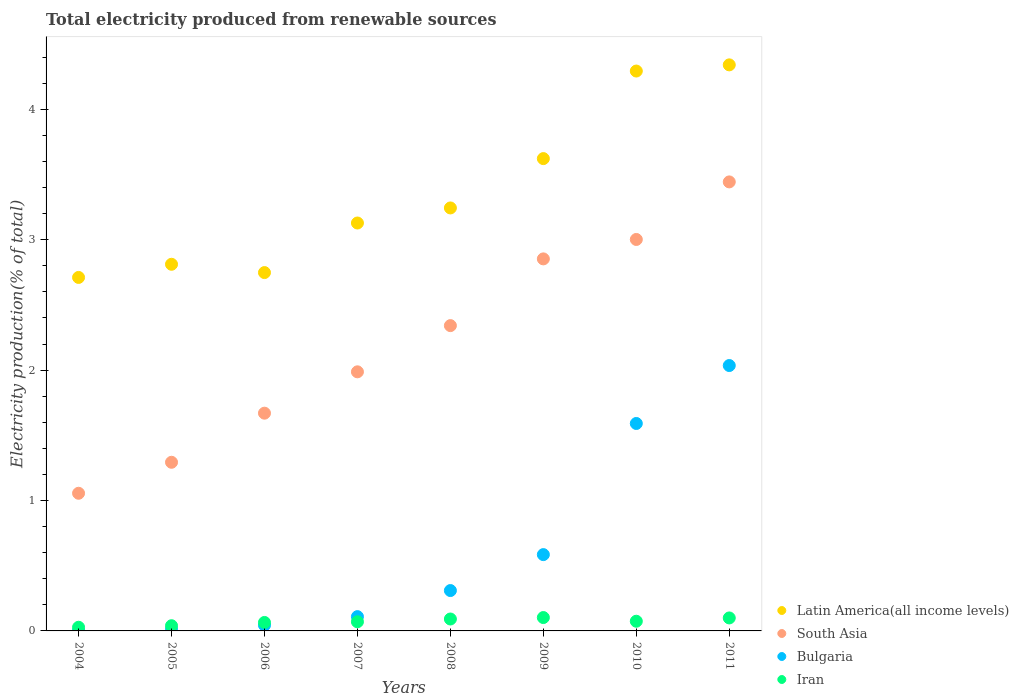Is the number of dotlines equal to the number of legend labels?
Offer a very short reply. Yes. What is the total electricity produced in Iran in 2010?
Offer a terse response. 0.07. Across all years, what is the maximum total electricity produced in South Asia?
Provide a short and direct response. 3.44. Across all years, what is the minimum total electricity produced in South Asia?
Keep it short and to the point. 1.06. In which year was the total electricity produced in South Asia maximum?
Your response must be concise. 2011. What is the total total electricity produced in Iran in the graph?
Keep it short and to the point. 0.57. What is the difference between the total electricity produced in Bulgaria in 2006 and that in 2009?
Keep it short and to the point. -0.54. What is the difference between the total electricity produced in Latin America(all income levels) in 2006 and the total electricity produced in Iran in 2011?
Your answer should be very brief. 2.65. What is the average total electricity produced in Iran per year?
Your response must be concise. 0.07. In the year 2008, what is the difference between the total electricity produced in Iran and total electricity produced in South Asia?
Offer a very short reply. -2.25. What is the ratio of the total electricity produced in Bulgaria in 2005 to that in 2008?
Make the answer very short. 0.04. Is the total electricity produced in Iran in 2007 less than that in 2008?
Make the answer very short. Yes. Is the difference between the total electricity produced in Iran in 2004 and 2009 greater than the difference between the total electricity produced in South Asia in 2004 and 2009?
Ensure brevity in your answer.  Yes. What is the difference between the highest and the second highest total electricity produced in Bulgaria?
Your answer should be compact. 0.44. What is the difference between the highest and the lowest total electricity produced in Bulgaria?
Make the answer very short. 2.03. In how many years, is the total electricity produced in Iran greater than the average total electricity produced in Iran taken over all years?
Your response must be concise. 4. Is it the case that in every year, the sum of the total electricity produced in Bulgaria and total electricity produced in Latin America(all income levels)  is greater than the sum of total electricity produced in Iran and total electricity produced in South Asia?
Your response must be concise. No. Is it the case that in every year, the sum of the total electricity produced in South Asia and total electricity produced in Iran  is greater than the total electricity produced in Latin America(all income levels)?
Provide a short and direct response. No. How many years are there in the graph?
Offer a very short reply. 8. What is the difference between two consecutive major ticks on the Y-axis?
Your answer should be very brief. 1. Are the values on the major ticks of Y-axis written in scientific E-notation?
Your response must be concise. No. Does the graph contain any zero values?
Keep it short and to the point. No. Does the graph contain grids?
Offer a terse response. No. How many legend labels are there?
Offer a very short reply. 4. What is the title of the graph?
Your answer should be very brief. Total electricity produced from renewable sources. What is the label or title of the X-axis?
Offer a terse response. Years. What is the label or title of the Y-axis?
Ensure brevity in your answer.  Electricity production(% of total). What is the Electricity production(% of total) in Latin America(all income levels) in 2004?
Provide a succinct answer. 2.71. What is the Electricity production(% of total) of South Asia in 2004?
Give a very brief answer. 1.06. What is the Electricity production(% of total) in Bulgaria in 2004?
Your answer should be very brief. 0. What is the Electricity production(% of total) in Iran in 2004?
Your answer should be very brief. 0.03. What is the Electricity production(% of total) in Latin America(all income levels) in 2005?
Your response must be concise. 2.81. What is the Electricity production(% of total) in South Asia in 2005?
Provide a short and direct response. 1.29. What is the Electricity production(% of total) in Bulgaria in 2005?
Keep it short and to the point. 0.01. What is the Electricity production(% of total) in Iran in 2005?
Provide a short and direct response. 0.04. What is the Electricity production(% of total) in Latin America(all income levels) in 2006?
Make the answer very short. 2.75. What is the Electricity production(% of total) in South Asia in 2006?
Keep it short and to the point. 1.67. What is the Electricity production(% of total) of Bulgaria in 2006?
Give a very brief answer. 0.04. What is the Electricity production(% of total) in Iran in 2006?
Ensure brevity in your answer.  0.06. What is the Electricity production(% of total) in Latin America(all income levels) in 2007?
Give a very brief answer. 3.13. What is the Electricity production(% of total) in South Asia in 2007?
Your answer should be very brief. 1.99. What is the Electricity production(% of total) in Bulgaria in 2007?
Keep it short and to the point. 0.11. What is the Electricity production(% of total) of Iran in 2007?
Ensure brevity in your answer.  0.07. What is the Electricity production(% of total) of Latin America(all income levels) in 2008?
Provide a succinct answer. 3.24. What is the Electricity production(% of total) of South Asia in 2008?
Ensure brevity in your answer.  2.34. What is the Electricity production(% of total) in Bulgaria in 2008?
Provide a short and direct response. 0.31. What is the Electricity production(% of total) in Iran in 2008?
Offer a terse response. 0.09. What is the Electricity production(% of total) of Latin America(all income levels) in 2009?
Your response must be concise. 3.62. What is the Electricity production(% of total) of South Asia in 2009?
Ensure brevity in your answer.  2.85. What is the Electricity production(% of total) in Bulgaria in 2009?
Keep it short and to the point. 0.59. What is the Electricity production(% of total) in Iran in 2009?
Offer a very short reply. 0.1. What is the Electricity production(% of total) in Latin America(all income levels) in 2010?
Your response must be concise. 4.29. What is the Electricity production(% of total) of South Asia in 2010?
Your response must be concise. 3. What is the Electricity production(% of total) in Bulgaria in 2010?
Provide a short and direct response. 1.59. What is the Electricity production(% of total) of Iran in 2010?
Keep it short and to the point. 0.07. What is the Electricity production(% of total) in Latin America(all income levels) in 2011?
Provide a short and direct response. 4.34. What is the Electricity production(% of total) in South Asia in 2011?
Your answer should be compact. 3.44. What is the Electricity production(% of total) in Bulgaria in 2011?
Make the answer very short. 2.04. What is the Electricity production(% of total) of Iran in 2011?
Your answer should be compact. 0.1. Across all years, what is the maximum Electricity production(% of total) in Latin America(all income levels)?
Offer a terse response. 4.34. Across all years, what is the maximum Electricity production(% of total) of South Asia?
Offer a very short reply. 3.44. Across all years, what is the maximum Electricity production(% of total) of Bulgaria?
Ensure brevity in your answer.  2.04. Across all years, what is the maximum Electricity production(% of total) in Iran?
Keep it short and to the point. 0.1. Across all years, what is the minimum Electricity production(% of total) in Latin America(all income levels)?
Offer a very short reply. 2.71. Across all years, what is the minimum Electricity production(% of total) in South Asia?
Provide a short and direct response. 1.06. Across all years, what is the minimum Electricity production(% of total) in Bulgaria?
Make the answer very short. 0. Across all years, what is the minimum Electricity production(% of total) of Iran?
Make the answer very short. 0.03. What is the total Electricity production(% of total) in Latin America(all income levels) in the graph?
Your answer should be compact. 26.9. What is the total Electricity production(% of total) in South Asia in the graph?
Offer a terse response. 17.64. What is the total Electricity production(% of total) in Bulgaria in the graph?
Provide a succinct answer. 4.69. What is the total Electricity production(% of total) in Iran in the graph?
Offer a very short reply. 0.57. What is the difference between the Electricity production(% of total) in Latin America(all income levels) in 2004 and that in 2005?
Make the answer very short. -0.1. What is the difference between the Electricity production(% of total) in South Asia in 2004 and that in 2005?
Provide a succinct answer. -0.24. What is the difference between the Electricity production(% of total) of Bulgaria in 2004 and that in 2005?
Provide a succinct answer. -0.01. What is the difference between the Electricity production(% of total) of Iran in 2004 and that in 2005?
Make the answer very short. -0.01. What is the difference between the Electricity production(% of total) in Latin America(all income levels) in 2004 and that in 2006?
Your answer should be very brief. -0.04. What is the difference between the Electricity production(% of total) in South Asia in 2004 and that in 2006?
Your answer should be very brief. -0.61. What is the difference between the Electricity production(% of total) in Bulgaria in 2004 and that in 2006?
Offer a terse response. -0.04. What is the difference between the Electricity production(% of total) of Iran in 2004 and that in 2006?
Keep it short and to the point. -0.04. What is the difference between the Electricity production(% of total) of Latin America(all income levels) in 2004 and that in 2007?
Your answer should be very brief. -0.42. What is the difference between the Electricity production(% of total) of South Asia in 2004 and that in 2007?
Your response must be concise. -0.93. What is the difference between the Electricity production(% of total) of Bulgaria in 2004 and that in 2007?
Provide a succinct answer. -0.11. What is the difference between the Electricity production(% of total) in Iran in 2004 and that in 2007?
Your answer should be very brief. -0.04. What is the difference between the Electricity production(% of total) in Latin America(all income levels) in 2004 and that in 2008?
Give a very brief answer. -0.53. What is the difference between the Electricity production(% of total) of South Asia in 2004 and that in 2008?
Your answer should be very brief. -1.29. What is the difference between the Electricity production(% of total) in Bulgaria in 2004 and that in 2008?
Offer a very short reply. -0.31. What is the difference between the Electricity production(% of total) in Iran in 2004 and that in 2008?
Your answer should be compact. -0.06. What is the difference between the Electricity production(% of total) in Latin America(all income levels) in 2004 and that in 2009?
Give a very brief answer. -0.91. What is the difference between the Electricity production(% of total) in South Asia in 2004 and that in 2009?
Make the answer very short. -1.8. What is the difference between the Electricity production(% of total) of Bulgaria in 2004 and that in 2009?
Offer a very short reply. -0.58. What is the difference between the Electricity production(% of total) in Iran in 2004 and that in 2009?
Offer a terse response. -0.07. What is the difference between the Electricity production(% of total) in Latin America(all income levels) in 2004 and that in 2010?
Offer a very short reply. -1.58. What is the difference between the Electricity production(% of total) in South Asia in 2004 and that in 2010?
Keep it short and to the point. -1.95. What is the difference between the Electricity production(% of total) in Bulgaria in 2004 and that in 2010?
Offer a very short reply. -1.59. What is the difference between the Electricity production(% of total) of Iran in 2004 and that in 2010?
Your answer should be very brief. -0.05. What is the difference between the Electricity production(% of total) of Latin America(all income levels) in 2004 and that in 2011?
Provide a short and direct response. -1.63. What is the difference between the Electricity production(% of total) in South Asia in 2004 and that in 2011?
Your answer should be compact. -2.39. What is the difference between the Electricity production(% of total) in Bulgaria in 2004 and that in 2011?
Keep it short and to the point. -2.03. What is the difference between the Electricity production(% of total) of Iran in 2004 and that in 2011?
Your answer should be compact. -0.07. What is the difference between the Electricity production(% of total) of Latin America(all income levels) in 2005 and that in 2006?
Give a very brief answer. 0.06. What is the difference between the Electricity production(% of total) of South Asia in 2005 and that in 2006?
Your response must be concise. -0.38. What is the difference between the Electricity production(% of total) of Bulgaria in 2005 and that in 2006?
Offer a terse response. -0.03. What is the difference between the Electricity production(% of total) of Iran in 2005 and that in 2006?
Your answer should be compact. -0.03. What is the difference between the Electricity production(% of total) in Latin America(all income levels) in 2005 and that in 2007?
Provide a succinct answer. -0.32. What is the difference between the Electricity production(% of total) of South Asia in 2005 and that in 2007?
Offer a very short reply. -0.69. What is the difference between the Electricity production(% of total) of Bulgaria in 2005 and that in 2007?
Ensure brevity in your answer.  -0.1. What is the difference between the Electricity production(% of total) of Iran in 2005 and that in 2007?
Ensure brevity in your answer.  -0.03. What is the difference between the Electricity production(% of total) in Latin America(all income levels) in 2005 and that in 2008?
Offer a very short reply. -0.43. What is the difference between the Electricity production(% of total) in South Asia in 2005 and that in 2008?
Ensure brevity in your answer.  -1.05. What is the difference between the Electricity production(% of total) of Bulgaria in 2005 and that in 2008?
Your answer should be very brief. -0.3. What is the difference between the Electricity production(% of total) in Iran in 2005 and that in 2008?
Offer a terse response. -0.05. What is the difference between the Electricity production(% of total) in Latin America(all income levels) in 2005 and that in 2009?
Your answer should be compact. -0.81. What is the difference between the Electricity production(% of total) of South Asia in 2005 and that in 2009?
Make the answer very short. -1.56. What is the difference between the Electricity production(% of total) of Bulgaria in 2005 and that in 2009?
Provide a succinct answer. -0.57. What is the difference between the Electricity production(% of total) in Iran in 2005 and that in 2009?
Your answer should be compact. -0.06. What is the difference between the Electricity production(% of total) in Latin America(all income levels) in 2005 and that in 2010?
Keep it short and to the point. -1.48. What is the difference between the Electricity production(% of total) of South Asia in 2005 and that in 2010?
Give a very brief answer. -1.71. What is the difference between the Electricity production(% of total) of Bulgaria in 2005 and that in 2010?
Provide a short and direct response. -1.58. What is the difference between the Electricity production(% of total) in Iran in 2005 and that in 2010?
Keep it short and to the point. -0.03. What is the difference between the Electricity production(% of total) of Latin America(all income levels) in 2005 and that in 2011?
Keep it short and to the point. -1.53. What is the difference between the Electricity production(% of total) in South Asia in 2005 and that in 2011?
Provide a succinct answer. -2.15. What is the difference between the Electricity production(% of total) of Bulgaria in 2005 and that in 2011?
Your answer should be very brief. -2.02. What is the difference between the Electricity production(% of total) in Iran in 2005 and that in 2011?
Provide a short and direct response. -0.06. What is the difference between the Electricity production(% of total) of Latin America(all income levels) in 2006 and that in 2007?
Make the answer very short. -0.38. What is the difference between the Electricity production(% of total) of South Asia in 2006 and that in 2007?
Provide a short and direct response. -0.32. What is the difference between the Electricity production(% of total) of Bulgaria in 2006 and that in 2007?
Keep it short and to the point. -0.07. What is the difference between the Electricity production(% of total) in Iran in 2006 and that in 2007?
Ensure brevity in your answer.  -0.01. What is the difference between the Electricity production(% of total) of Latin America(all income levels) in 2006 and that in 2008?
Provide a short and direct response. -0.5. What is the difference between the Electricity production(% of total) in South Asia in 2006 and that in 2008?
Offer a very short reply. -0.67. What is the difference between the Electricity production(% of total) in Bulgaria in 2006 and that in 2008?
Your response must be concise. -0.27. What is the difference between the Electricity production(% of total) of Iran in 2006 and that in 2008?
Ensure brevity in your answer.  -0.03. What is the difference between the Electricity production(% of total) in Latin America(all income levels) in 2006 and that in 2009?
Your response must be concise. -0.87. What is the difference between the Electricity production(% of total) of South Asia in 2006 and that in 2009?
Give a very brief answer. -1.18. What is the difference between the Electricity production(% of total) in Bulgaria in 2006 and that in 2009?
Provide a succinct answer. -0.54. What is the difference between the Electricity production(% of total) of Iran in 2006 and that in 2009?
Your answer should be very brief. -0.04. What is the difference between the Electricity production(% of total) of Latin America(all income levels) in 2006 and that in 2010?
Keep it short and to the point. -1.55. What is the difference between the Electricity production(% of total) in South Asia in 2006 and that in 2010?
Your answer should be compact. -1.33. What is the difference between the Electricity production(% of total) of Bulgaria in 2006 and that in 2010?
Make the answer very short. -1.55. What is the difference between the Electricity production(% of total) of Iran in 2006 and that in 2010?
Offer a very short reply. -0.01. What is the difference between the Electricity production(% of total) in Latin America(all income levels) in 2006 and that in 2011?
Ensure brevity in your answer.  -1.59. What is the difference between the Electricity production(% of total) in South Asia in 2006 and that in 2011?
Give a very brief answer. -1.77. What is the difference between the Electricity production(% of total) of Bulgaria in 2006 and that in 2011?
Provide a short and direct response. -1.99. What is the difference between the Electricity production(% of total) in Iran in 2006 and that in 2011?
Ensure brevity in your answer.  -0.03. What is the difference between the Electricity production(% of total) of Latin America(all income levels) in 2007 and that in 2008?
Your response must be concise. -0.12. What is the difference between the Electricity production(% of total) of South Asia in 2007 and that in 2008?
Provide a short and direct response. -0.35. What is the difference between the Electricity production(% of total) of Bulgaria in 2007 and that in 2008?
Give a very brief answer. -0.2. What is the difference between the Electricity production(% of total) in Iran in 2007 and that in 2008?
Your answer should be very brief. -0.02. What is the difference between the Electricity production(% of total) of Latin America(all income levels) in 2007 and that in 2009?
Make the answer very short. -0.49. What is the difference between the Electricity production(% of total) in South Asia in 2007 and that in 2009?
Keep it short and to the point. -0.87. What is the difference between the Electricity production(% of total) in Bulgaria in 2007 and that in 2009?
Make the answer very short. -0.48. What is the difference between the Electricity production(% of total) of Iran in 2007 and that in 2009?
Make the answer very short. -0.03. What is the difference between the Electricity production(% of total) in Latin America(all income levels) in 2007 and that in 2010?
Give a very brief answer. -1.17. What is the difference between the Electricity production(% of total) in South Asia in 2007 and that in 2010?
Make the answer very short. -1.01. What is the difference between the Electricity production(% of total) in Bulgaria in 2007 and that in 2010?
Ensure brevity in your answer.  -1.48. What is the difference between the Electricity production(% of total) in Iran in 2007 and that in 2010?
Give a very brief answer. -0. What is the difference between the Electricity production(% of total) in Latin America(all income levels) in 2007 and that in 2011?
Ensure brevity in your answer.  -1.21. What is the difference between the Electricity production(% of total) in South Asia in 2007 and that in 2011?
Ensure brevity in your answer.  -1.46. What is the difference between the Electricity production(% of total) in Bulgaria in 2007 and that in 2011?
Keep it short and to the point. -1.93. What is the difference between the Electricity production(% of total) of Iran in 2007 and that in 2011?
Provide a short and direct response. -0.03. What is the difference between the Electricity production(% of total) of Latin America(all income levels) in 2008 and that in 2009?
Your response must be concise. -0.38. What is the difference between the Electricity production(% of total) in South Asia in 2008 and that in 2009?
Your response must be concise. -0.51. What is the difference between the Electricity production(% of total) in Bulgaria in 2008 and that in 2009?
Offer a terse response. -0.28. What is the difference between the Electricity production(% of total) in Iran in 2008 and that in 2009?
Make the answer very short. -0.01. What is the difference between the Electricity production(% of total) of Latin America(all income levels) in 2008 and that in 2010?
Your response must be concise. -1.05. What is the difference between the Electricity production(% of total) in South Asia in 2008 and that in 2010?
Provide a short and direct response. -0.66. What is the difference between the Electricity production(% of total) in Bulgaria in 2008 and that in 2010?
Offer a very short reply. -1.28. What is the difference between the Electricity production(% of total) of Iran in 2008 and that in 2010?
Provide a succinct answer. 0.02. What is the difference between the Electricity production(% of total) in Latin America(all income levels) in 2008 and that in 2011?
Make the answer very short. -1.1. What is the difference between the Electricity production(% of total) in South Asia in 2008 and that in 2011?
Offer a terse response. -1.1. What is the difference between the Electricity production(% of total) in Bulgaria in 2008 and that in 2011?
Provide a succinct answer. -1.73. What is the difference between the Electricity production(% of total) in Iran in 2008 and that in 2011?
Your response must be concise. -0.01. What is the difference between the Electricity production(% of total) in Latin America(all income levels) in 2009 and that in 2010?
Ensure brevity in your answer.  -0.67. What is the difference between the Electricity production(% of total) of South Asia in 2009 and that in 2010?
Your response must be concise. -0.15. What is the difference between the Electricity production(% of total) in Bulgaria in 2009 and that in 2010?
Offer a very short reply. -1.01. What is the difference between the Electricity production(% of total) in Iran in 2009 and that in 2010?
Give a very brief answer. 0.03. What is the difference between the Electricity production(% of total) in Latin America(all income levels) in 2009 and that in 2011?
Offer a terse response. -0.72. What is the difference between the Electricity production(% of total) in South Asia in 2009 and that in 2011?
Your answer should be very brief. -0.59. What is the difference between the Electricity production(% of total) in Bulgaria in 2009 and that in 2011?
Your response must be concise. -1.45. What is the difference between the Electricity production(% of total) of Iran in 2009 and that in 2011?
Keep it short and to the point. 0. What is the difference between the Electricity production(% of total) in Latin America(all income levels) in 2010 and that in 2011?
Keep it short and to the point. -0.05. What is the difference between the Electricity production(% of total) in South Asia in 2010 and that in 2011?
Keep it short and to the point. -0.44. What is the difference between the Electricity production(% of total) in Bulgaria in 2010 and that in 2011?
Ensure brevity in your answer.  -0.44. What is the difference between the Electricity production(% of total) of Iran in 2010 and that in 2011?
Make the answer very short. -0.03. What is the difference between the Electricity production(% of total) of Latin America(all income levels) in 2004 and the Electricity production(% of total) of South Asia in 2005?
Offer a terse response. 1.42. What is the difference between the Electricity production(% of total) in Latin America(all income levels) in 2004 and the Electricity production(% of total) in Bulgaria in 2005?
Your answer should be compact. 2.7. What is the difference between the Electricity production(% of total) in Latin America(all income levels) in 2004 and the Electricity production(% of total) in Iran in 2005?
Keep it short and to the point. 2.67. What is the difference between the Electricity production(% of total) of South Asia in 2004 and the Electricity production(% of total) of Bulgaria in 2005?
Make the answer very short. 1.04. What is the difference between the Electricity production(% of total) of South Asia in 2004 and the Electricity production(% of total) of Iran in 2005?
Offer a terse response. 1.02. What is the difference between the Electricity production(% of total) of Bulgaria in 2004 and the Electricity production(% of total) of Iran in 2005?
Offer a terse response. -0.04. What is the difference between the Electricity production(% of total) of Latin America(all income levels) in 2004 and the Electricity production(% of total) of South Asia in 2006?
Provide a succinct answer. 1.04. What is the difference between the Electricity production(% of total) in Latin America(all income levels) in 2004 and the Electricity production(% of total) in Bulgaria in 2006?
Offer a terse response. 2.67. What is the difference between the Electricity production(% of total) of Latin America(all income levels) in 2004 and the Electricity production(% of total) of Iran in 2006?
Your response must be concise. 2.65. What is the difference between the Electricity production(% of total) of South Asia in 2004 and the Electricity production(% of total) of Bulgaria in 2006?
Provide a short and direct response. 1.01. What is the difference between the Electricity production(% of total) in South Asia in 2004 and the Electricity production(% of total) in Iran in 2006?
Your answer should be compact. 0.99. What is the difference between the Electricity production(% of total) in Bulgaria in 2004 and the Electricity production(% of total) in Iran in 2006?
Provide a succinct answer. -0.06. What is the difference between the Electricity production(% of total) in Latin America(all income levels) in 2004 and the Electricity production(% of total) in South Asia in 2007?
Your response must be concise. 0.72. What is the difference between the Electricity production(% of total) of Latin America(all income levels) in 2004 and the Electricity production(% of total) of Bulgaria in 2007?
Offer a very short reply. 2.6. What is the difference between the Electricity production(% of total) in Latin America(all income levels) in 2004 and the Electricity production(% of total) in Iran in 2007?
Your answer should be compact. 2.64. What is the difference between the Electricity production(% of total) in South Asia in 2004 and the Electricity production(% of total) in Bulgaria in 2007?
Your answer should be very brief. 0.95. What is the difference between the Electricity production(% of total) of South Asia in 2004 and the Electricity production(% of total) of Iran in 2007?
Provide a short and direct response. 0.99. What is the difference between the Electricity production(% of total) of Bulgaria in 2004 and the Electricity production(% of total) of Iran in 2007?
Make the answer very short. -0.07. What is the difference between the Electricity production(% of total) in Latin America(all income levels) in 2004 and the Electricity production(% of total) in South Asia in 2008?
Provide a succinct answer. 0.37. What is the difference between the Electricity production(% of total) in Latin America(all income levels) in 2004 and the Electricity production(% of total) in Bulgaria in 2008?
Offer a very short reply. 2.4. What is the difference between the Electricity production(% of total) in Latin America(all income levels) in 2004 and the Electricity production(% of total) in Iran in 2008?
Keep it short and to the point. 2.62. What is the difference between the Electricity production(% of total) in South Asia in 2004 and the Electricity production(% of total) in Bulgaria in 2008?
Give a very brief answer. 0.75. What is the difference between the Electricity production(% of total) in South Asia in 2004 and the Electricity production(% of total) in Iran in 2008?
Offer a very short reply. 0.96. What is the difference between the Electricity production(% of total) of Bulgaria in 2004 and the Electricity production(% of total) of Iran in 2008?
Offer a very short reply. -0.09. What is the difference between the Electricity production(% of total) in Latin America(all income levels) in 2004 and the Electricity production(% of total) in South Asia in 2009?
Offer a very short reply. -0.14. What is the difference between the Electricity production(% of total) in Latin America(all income levels) in 2004 and the Electricity production(% of total) in Bulgaria in 2009?
Your answer should be compact. 2.13. What is the difference between the Electricity production(% of total) in Latin America(all income levels) in 2004 and the Electricity production(% of total) in Iran in 2009?
Make the answer very short. 2.61. What is the difference between the Electricity production(% of total) in South Asia in 2004 and the Electricity production(% of total) in Bulgaria in 2009?
Offer a very short reply. 0.47. What is the difference between the Electricity production(% of total) in South Asia in 2004 and the Electricity production(% of total) in Iran in 2009?
Ensure brevity in your answer.  0.95. What is the difference between the Electricity production(% of total) in Bulgaria in 2004 and the Electricity production(% of total) in Iran in 2009?
Your answer should be very brief. -0.1. What is the difference between the Electricity production(% of total) of Latin America(all income levels) in 2004 and the Electricity production(% of total) of South Asia in 2010?
Offer a very short reply. -0.29. What is the difference between the Electricity production(% of total) of Latin America(all income levels) in 2004 and the Electricity production(% of total) of Bulgaria in 2010?
Your answer should be compact. 1.12. What is the difference between the Electricity production(% of total) in Latin America(all income levels) in 2004 and the Electricity production(% of total) in Iran in 2010?
Offer a very short reply. 2.64. What is the difference between the Electricity production(% of total) in South Asia in 2004 and the Electricity production(% of total) in Bulgaria in 2010?
Provide a succinct answer. -0.54. What is the difference between the Electricity production(% of total) of South Asia in 2004 and the Electricity production(% of total) of Iran in 2010?
Offer a very short reply. 0.98. What is the difference between the Electricity production(% of total) of Bulgaria in 2004 and the Electricity production(% of total) of Iran in 2010?
Offer a terse response. -0.07. What is the difference between the Electricity production(% of total) of Latin America(all income levels) in 2004 and the Electricity production(% of total) of South Asia in 2011?
Offer a terse response. -0.73. What is the difference between the Electricity production(% of total) of Latin America(all income levels) in 2004 and the Electricity production(% of total) of Bulgaria in 2011?
Your answer should be compact. 0.68. What is the difference between the Electricity production(% of total) of Latin America(all income levels) in 2004 and the Electricity production(% of total) of Iran in 2011?
Make the answer very short. 2.61. What is the difference between the Electricity production(% of total) in South Asia in 2004 and the Electricity production(% of total) in Bulgaria in 2011?
Provide a short and direct response. -0.98. What is the difference between the Electricity production(% of total) in South Asia in 2004 and the Electricity production(% of total) in Iran in 2011?
Your answer should be very brief. 0.96. What is the difference between the Electricity production(% of total) in Bulgaria in 2004 and the Electricity production(% of total) in Iran in 2011?
Offer a terse response. -0.1. What is the difference between the Electricity production(% of total) in Latin America(all income levels) in 2005 and the Electricity production(% of total) in South Asia in 2006?
Provide a short and direct response. 1.14. What is the difference between the Electricity production(% of total) in Latin America(all income levels) in 2005 and the Electricity production(% of total) in Bulgaria in 2006?
Offer a very short reply. 2.77. What is the difference between the Electricity production(% of total) in Latin America(all income levels) in 2005 and the Electricity production(% of total) in Iran in 2006?
Provide a short and direct response. 2.75. What is the difference between the Electricity production(% of total) of South Asia in 2005 and the Electricity production(% of total) of Bulgaria in 2006?
Your answer should be compact. 1.25. What is the difference between the Electricity production(% of total) in South Asia in 2005 and the Electricity production(% of total) in Iran in 2006?
Make the answer very short. 1.23. What is the difference between the Electricity production(% of total) of Bulgaria in 2005 and the Electricity production(% of total) of Iran in 2006?
Your response must be concise. -0.05. What is the difference between the Electricity production(% of total) of Latin America(all income levels) in 2005 and the Electricity production(% of total) of South Asia in 2007?
Give a very brief answer. 0.82. What is the difference between the Electricity production(% of total) of Latin America(all income levels) in 2005 and the Electricity production(% of total) of Bulgaria in 2007?
Give a very brief answer. 2.7. What is the difference between the Electricity production(% of total) in Latin America(all income levels) in 2005 and the Electricity production(% of total) in Iran in 2007?
Make the answer very short. 2.74. What is the difference between the Electricity production(% of total) of South Asia in 2005 and the Electricity production(% of total) of Bulgaria in 2007?
Give a very brief answer. 1.18. What is the difference between the Electricity production(% of total) of South Asia in 2005 and the Electricity production(% of total) of Iran in 2007?
Make the answer very short. 1.22. What is the difference between the Electricity production(% of total) of Bulgaria in 2005 and the Electricity production(% of total) of Iran in 2007?
Offer a terse response. -0.06. What is the difference between the Electricity production(% of total) in Latin America(all income levels) in 2005 and the Electricity production(% of total) in South Asia in 2008?
Provide a succinct answer. 0.47. What is the difference between the Electricity production(% of total) in Latin America(all income levels) in 2005 and the Electricity production(% of total) in Bulgaria in 2008?
Offer a terse response. 2.5. What is the difference between the Electricity production(% of total) in Latin America(all income levels) in 2005 and the Electricity production(% of total) in Iran in 2008?
Ensure brevity in your answer.  2.72. What is the difference between the Electricity production(% of total) in South Asia in 2005 and the Electricity production(% of total) in Bulgaria in 2008?
Ensure brevity in your answer.  0.98. What is the difference between the Electricity production(% of total) in South Asia in 2005 and the Electricity production(% of total) in Iran in 2008?
Give a very brief answer. 1.2. What is the difference between the Electricity production(% of total) in Bulgaria in 2005 and the Electricity production(% of total) in Iran in 2008?
Offer a very short reply. -0.08. What is the difference between the Electricity production(% of total) in Latin America(all income levels) in 2005 and the Electricity production(% of total) in South Asia in 2009?
Provide a short and direct response. -0.04. What is the difference between the Electricity production(% of total) of Latin America(all income levels) in 2005 and the Electricity production(% of total) of Bulgaria in 2009?
Your answer should be very brief. 2.23. What is the difference between the Electricity production(% of total) in Latin America(all income levels) in 2005 and the Electricity production(% of total) in Iran in 2009?
Make the answer very short. 2.71. What is the difference between the Electricity production(% of total) of South Asia in 2005 and the Electricity production(% of total) of Bulgaria in 2009?
Your response must be concise. 0.71. What is the difference between the Electricity production(% of total) of South Asia in 2005 and the Electricity production(% of total) of Iran in 2009?
Your response must be concise. 1.19. What is the difference between the Electricity production(% of total) of Bulgaria in 2005 and the Electricity production(% of total) of Iran in 2009?
Your answer should be compact. -0.09. What is the difference between the Electricity production(% of total) of Latin America(all income levels) in 2005 and the Electricity production(% of total) of South Asia in 2010?
Provide a short and direct response. -0.19. What is the difference between the Electricity production(% of total) in Latin America(all income levels) in 2005 and the Electricity production(% of total) in Bulgaria in 2010?
Make the answer very short. 1.22. What is the difference between the Electricity production(% of total) of Latin America(all income levels) in 2005 and the Electricity production(% of total) of Iran in 2010?
Ensure brevity in your answer.  2.74. What is the difference between the Electricity production(% of total) in South Asia in 2005 and the Electricity production(% of total) in Bulgaria in 2010?
Your answer should be very brief. -0.3. What is the difference between the Electricity production(% of total) of South Asia in 2005 and the Electricity production(% of total) of Iran in 2010?
Offer a terse response. 1.22. What is the difference between the Electricity production(% of total) of Bulgaria in 2005 and the Electricity production(% of total) of Iran in 2010?
Your answer should be very brief. -0.06. What is the difference between the Electricity production(% of total) of Latin America(all income levels) in 2005 and the Electricity production(% of total) of South Asia in 2011?
Your answer should be very brief. -0.63. What is the difference between the Electricity production(% of total) of Latin America(all income levels) in 2005 and the Electricity production(% of total) of Bulgaria in 2011?
Your response must be concise. 0.78. What is the difference between the Electricity production(% of total) of Latin America(all income levels) in 2005 and the Electricity production(% of total) of Iran in 2011?
Ensure brevity in your answer.  2.71. What is the difference between the Electricity production(% of total) of South Asia in 2005 and the Electricity production(% of total) of Bulgaria in 2011?
Your answer should be compact. -0.74. What is the difference between the Electricity production(% of total) of South Asia in 2005 and the Electricity production(% of total) of Iran in 2011?
Give a very brief answer. 1.19. What is the difference between the Electricity production(% of total) in Bulgaria in 2005 and the Electricity production(% of total) in Iran in 2011?
Provide a succinct answer. -0.09. What is the difference between the Electricity production(% of total) of Latin America(all income levels) in 2006 and the Electricity production(% of total) of South Asia in 2007?
Give a very brief answer. 0.76. What is the difference between the Electricity production(% of total) in Latin America(all income levels) in 2006 and the Electricity production(% of total) in Bulgaria in 2007?
Ensure brevity in your answer.  2.64. What is the difference between the Electricity production(% of total) in Latin America(all income levels) in 2006 and the Electricity production(% of total) in Iran in 2007?
Offer a very short reply. 2.68. What is the difference between the Electricity production(% of total) of South Asia in 2006 and the Electricity production(% of total) of Bulgaria in 2007?
Your response must be concise. 1.56. What is the difference between the Electricity production(% of total) of South Asia in 2006 and the Electricity production(% of total) of Iran in 2007?
Your response must be concise. 1.6. What is the difference between the Electricity production(% of total) in Bulgaria in 2006 and the Electricity production(% of total) in Iran in 2007?
Provide a succinct answer. -0.03. What is the difference between the Electricity production(% of total) of Latin America(all income levels) in 2006 and the Electricity production(% of total) of South Asia in 2008?
Your answer should be very brief. 0.41. What is the difference between the Electricity production(% of total) in Latin America(all income levels) in 2006 and the Electricity production(% of total) in Bulgaria in 2008?
Your answer should be compact. 2.44. What is the difference between the Electricity production(% of total) of Latin America(all income levels) in 2006 and the Electricity production(% of total) of Iran in 2008?
Give a very brief answer. 2.66. What is the difference between the Electricity production(% of total) in South Asia in 2006 and the Electricity production(% of total) in Bulgaria in 2008?
Your answer should be compact. 1.36. What is the difference between the Electricity production(% of total) in South Asia in 2006 and the Electricity production(% of total) in Iran in 2008?
Provide a succinct answer. 1.58. What is the difference between the Electricity production(% of total) of Bulgaria in 2006 and the Electricity production(% of total) of Iran in 2008?
Offer a very short reply. -0.05. What is the difference between the Electricity production(% of total) in Latin America(all income levels) in 2006 and the Electricity production(% of total) in South Asia in 2009?
Give a very brief answer. -0.1. What is the difference between the Electricity production(% of total) of Latin America(all income levels) in 2006 and the Electricity production(% of total) of Bulgaria in 2009?
Provide a succinct answer. 2.16. What is the difference between the Electricity production(% of total) of Latin America(all income levels) in 2006 and the Electricity production(% of total) of Iran in 2009?
Provide a succinct answer. 2.65. What is the difference between the Electricity production(% of total) of South Asia in 2006 and the Electricity production(% of total) of Bulgaria in 2009?
Your response must be concise. 1.08. What is the difference between the Electricity production(% of total) in South Asia in 2006 and the Electricity production(% of total) in Iran in 2009?
Give a very brief answer. 1.57. What is the difference between the Electricity production(% of total) in Bulgaria in 2006 and the Electricity production(% of total) in Iran in 2009?
Offer a terse response. -0.06. What is the difference between the Electricity production(% of total) of Latin America(all income levels) in 2006 and the Electricity production(% of total) of South Asia in 2010?
Provide a short and direct response. -0.25. What is the difference between the Electricity production(% of total) in Latin America(all income levels) in 2006 and the Electricity production(% of total) in Bulgaria in 2010?
Provide a short and direct response. 1.16. What is the difference between the Electricity production(% of total) of Latin America(all income levels) in 2006 and the Electricity production(% of total) of Iran in 2010?
Provide a short and direct response. 2.67. What is the difference between the Electricity production(% of total) in South Asia in 2006 and the Electricity production(% of total) in Bulgaria in 2010?
Ensure brevity in your answer.  0.08. What is the difference between the Electricity production(% of total) in South Asia in 2006 and the Electricity production(% of total) in Iran in 2010?
Your answer should be very brief. 1.6. What is the difference between the Electricity production(% of total) of Bulgaria in 2006 and the Electricity production(% of total) of Iran in 2010?
Ensure brevity in your answer.  -0.03. What is the difference between the Electricity production(% of total) of Latin America(all income levels) in 2006 and the Electricity production(% of total) of South Asia in 2011?
Provide a short and direct response. -0.7. What is the difference between the Electricity production(% of total) in Latin America(all income levels) in 2006 and the Electricity production(% of total) in Bulgaria in 2011?
Provide a short and direct response. 0.71. What is the difference between the Electricity production(% of total) of Latin America(all income levels) in 2006 and the Electricity production(% of total) of Iran in 2011?
Your answer should be very brief. 2.65. What is the difference between the Electricity production(% of total) in South Asia in 2006 and the Electricity production(% of total) in Bulgaria in 2011?
Offer a terse response. -0.37. What is the difference between the Electricity production(% of total) of South Asia in 2006 and the Electricity production(% of total) of Iran in 2011?
Your answer should be very brief. 1.57. What is the difference between the Electricity production(% of total) of Bulgaria in 2006 and the Electricity production(% of total) of Iran in 2011?
Keep it short and to the point. -0.06. What is the difference between the Electricity production(% of total) in Latin America(all income levels) in 2007 and the Electricity production(% of total) in South Asia in 2008?
Offer a very short reply. 0.79. What is the difference between the Electricity production(% of total) of Latin America(all income levels) in 2007 and the Electricity production(% of total) of Bulgaria in 2008?
Your answer should be very brief. 2.82. What is the difference between the Electricity production(% of total) of Latin America(all income levels) in 2007 and the Electricity production(% of total) of Iran in 2008?
Provide a succinct answer. 3.04. What is the difference between the Electricity production(% of total) in South Asia in 2007 and the Electricity production(% of total) in Bulgaria in 2008?
Your answer should be compact. 1.68. What is the difference between the Electricity production(% of total) of South Asia in 2007 and the Electricity production(% of total) of Iran in 2008?
Give a very brief answer. 1.9. What is the difference between the Electricity production(% of total) in Bulgaria in 2007 and the Electricity production(% of total) in Iran in 2008?
Your answer should be very brief. 0.02. What is the difference between the Electricity production(% of total) of Latin America(all income levels) in 2007 and the Electricity production(% of total) of South Asia in 2009?
Your answer should be very brief. 0.28. What is the difference between the Electricity production(% of total) of Latin America(all income levels) in 2007 and the Electricity production(% of total) of Bulgaria in 2009?
Provide a succinct answer. 2.54. What is the difference between the Electricity production(% of total) in Latin America(all income levels) in 2007 and the Electricity production(% of total) in Iran in 2009?
Offer a terse response. 3.03. What is the difference between the Electricity production(% of total) in South Asia in 2007 and the Electricity production(% of total) in Bulgaria in 2009?
Your answer should be compact. 1.4. What is the difference between the Electricity production(% of total) of South Asia in 2007 and the Electricity production(% of total) of Iran in 2009?
Offer a terse response. 1.88. What is the difference between the Electricity production(% of total) of Bulgaria in 2007 and the Electricity production(% of total) of Iran in 2009?
Give a very brief answer. 0.01. What is the difference between the Electricity production(% of total) of Latin America(all income levels) in 2007 and the Electricity production(% of total) of South Asia in 2010?
Make the answer very short. 0.13. What is the difference between the Electricity production(% of total) in Latin America(all income levels) in 2007 and the Electricity production(% of total) in Bulgaria in 2010?
Provide a short and direct response. 1.54. What is the difference between the Electricity production(% of total) of Latin America(all income levels) in 2007 and the Electricity production(% of total) of Iran in 2010?
Provide a short and direct response. 3.05. What is the difference between the Electricity production(% of total) in South Asia in 2007 and the Electricity production(% of total) in Bulgaria in 2010?
Your answer should be very brief. 0.4. What is the difference between the Electricity production(% of total) in South Asia in 2007 and the Electricity production(% of total) in Iran in 2010?
Provide a short and direct response. 1.91. What is the difference between the Electricity production(% of total) in Bulgaria in 2007 and the Electricity production(% of total) in Iran in 2010?
Offer a very short reply. 0.04. What is the difference between the Electricity production(% of total) in Latin America(all income levels) in 2007 and the Electricity production(% of total) in South Asia in 2011?
Make the answer very short. -0.32. What is the difference between the Electricity production(% of total) in Latin America(all income levels) in 2007 and the Electricity production(% of total) in Bulgaria in 2011?
Keep it short and to the point. 1.09. What is the difference between the Electricity production(% of total) of Latin America(all income levels) in 2007 and the Electricity production(% of total) of Iran in 2011?
Provide a succinct answer. 3.03. What is the difference between the Electricity production(% of total) of South Asia in 2007 and the Electricity production(% of total) of Bulgaria in 2011?
Ensure brevity in your answer.  -0.05. What is the difference between the Electricity production(% of total) of South Asia in 2007 and the Electricity production(% of total) of Iran in 2011?
Offer a very short reply. 1.89. What is the difference between the Electricity production(% of total) of Bulgaria in 2007 and the Electricity production(% of total) of Iran in 2011?
Offer a terse response. 0.01. What is the difference between the Electricity production(% of total) in Latin America(all income levels) in 2008 and the Electricity production(% of total) in South Asia in 2009?
Offer a terse response. 0.39. What is the difference between the Electricity production(% of total) in Latin America(all income levels) in 2008 and the Electricity production(% of total) in Bulgaria in 2009?
Your answer should be very brief. 2.66. What is the difference between the Electricity production(% of total) in Latin America(all income levels) in 2008 and the Electricity production(% of total) in Iran in 2009?
Your answer should be very brief. 3.14. What is the difference between the Electricity production(% of total) in South Asia in 2008 and the Electricity production(% of total) in Bulgaria in 2009?
Your answer should be very brief. 1.76. What is the difference between the Electricity production(% of total) in South Asia in 2008 and the Electricity production(% of total) in Iran in 2009?
Ensure brevity in your answer.  2.24. What is the difference between the Electricity production(% of total) of Bulgaria in 2008 and the Electricity production(% of total) of Iran in 2009?
Provide a short and direct response. 0.21. What is the difference between the Electricity production(% of total) of Latin America(all income levels) in 2008 and the Electricity production(% of total) of South Asia in 2010?
Provide a short and direct response. 0.24. What is the difference between the Electricity production(% of total) of Latin America(all income levels) in 2008 and the Electricity production(% of total) of Bulgaria in 2010?
Provide a succinct answer. 1.65. What is the difference between the Electricity production(% of total) of Latin America(all income levels) in 2008 and the Electricity production(% of total) of Iran in 2010?
Make the answer very short. 3.17. What is the difference between the Electricity production(% of total) of South Asia in 2008 and the Electricity production(% of total) of Bulgaria in 2010?
Offer a terse response. 0.75. What is the difference between the Electricity production(% of total) of South Asia in 2008 and the Electricity production(% of total) of Iran in 2010?
Your answer should be very brief. 2.27. What is the difference between the Electricity production(% of total) of Bulgaria in 2008 and the Electricity production(% of total) of Iran in 2010?
Your answer should be very brief. 0.24. What is the difference between the Electricity production(% of total) in Latin America(all income levels) in 2008 and the Electricity production(% of total) in South Asia in 2011?
Keep it short and to the point. -0.2. What is the difference between the Electricity production(% of total) in Latin America(all income levels) in 2008 and the Electricity production(% of total) in Bulgaria in 2011?
Give a very brief answer. 1.21. What is the difference between the Electricity production(% of total) in Latin America(all income levels) in 2008 and the Electricity production(% of total) in Iran in 2011?
Give a very brief answer. 3.14. What is the difference between the Electricity production(% of total) of South Asia in 2008 and the Electricity production(% of total) of Bulgaria in 2011?
Give a very brief answer. 0.31. What is the difference between the Electricity production(% of total) in South Asia in 2008 and the Electricity production(% of total) in Iran in 2011?
Provide a short and direct response. 2.24. What is the difference between the Electricity production(% of total) of Bulgaria in 2008 and the Electricity production(% of total) of Iran in 2011?
Your answer should be very brief. 0.21. What is the difference between the Electricity production(% of total) of Latin America(all income levels) in 2009 and the Electricity production(% of total) of South Asia in 2010?
Offer a very short reply. 0.62. What is the difference between the Electricity production(% of total) in Latin America(all income levels) in 2009 and the Electricity production(% of total) in Bulgaria in 2010?
Make the answer very short. 2.03. What is the difference between the Electricity production(% of total) of Latin America(all income levels) in 2009 and the Electricity production(% of total) of Iran in 2010?
Provide a short and direct response. 3.55. What is the difference between the Electricity production(% of total) in South Asia in 2009 and the Electricity production(% of total) in Bulgaria in 2010?
Ensure brevity in your answer.  1.26. What is the difference between the Electricity production(% of total) in South Asia in 2009 and the Electricity production(% of total) in Iran in 2010?
Provide a short and direct response. 2.78. What is the difference between the Electricity production(% of total) of Bulgaria in 2009 and the Electricity production(% of total) of Iran in 2010?
Offer a terse response. 0.51. What is the difference between the Electricity production(% of total) in Latin America(all income levels) in 2009 and the Electricity production(% of total) in South Asia in 2011?
Your answer should be very brief. 0.18. What is the difference between the Electricity production(% of total) of Latin America(all income levels) in 2009 and the Electricity production(% of total) of Bulgaria in 2011?
Make the answer very short. 1.59. What is the difference between the Electricity production(% of total) of Latin America(all income levels) in 2009 and the Electricity production(% of total) of Iran in 2011?
Your answer should be compact. 3.52. What is the difference between the Electricity production(% of total) of South Asia in 2009 and the Electricity production(% of total) of Bulgaria in 2011?
Your answer should be compact. 0.82. What is the difference between the Electricity production(% of total) in South Asia in 2009 and the Electricity production(% of total) in Iran in 2011?
Your answer should be very brief. 2.75. What is the difference between the Electricity production(% of total) of Bulgaria in 2009 and the Electricity production(% of total) of Iran in 2011?
Keep it short and to the point. 0.49. What is the difference between the Electricity production(% of total) of Latin America(all income levels) in 2010 and the Electricity production(% of total) of South Asia in 2011?
Ensure brevity in your answer.  0.85. What is the difference between the Electricity production(% of total) in Latin America(all income levels) in 2010 and the Electricity production(% of total) in Bulgaria in 2011?
Provide a succinct answer. 2.26. What is the difference between the Electricity production(% of total) of Latin America(all income levels) in 2010 and the Electricity production(% of total) of Iran in 2011?
Make the answer very short. 4.19. What is the difference between the Electricity production(% of total) of South Asia in 2010 and the Electricity production(% of total) of Bulgaria in 2011?
Your response must be concise. 0.97. What is the difference between the Electricity production(% of total) of South Asia in 2010 and the Electricity production(% of total) of Iran in 2011?
Your answer should be compact. 2.9. What is the difference between the Electricity production(% of total) in Bulgaria in 2010 and the Electricity production(% of total) in Iran in 2011?
Keep it short and to the point. 1.49. What is the average Electricity production(% of total) in Latin America(all income levels) per year?
Make the answer very short. 3.36. What is the average Electricity production(% of total) in South Asia per year?
Provide a succinct answer. 2.21. What is the average Electricity production(% of total) in Bulgaria per year?
Make the answer very short. 0.59. What is the average Electricity production(% of total) of Iran per year?
Your answer should be compact. 0.07. In the year 2004, what is the difference between the Electricity production(% of total) in Latin America(all income levels) and Electricity production(% of total) in South Asia?
Provide a short and direct response. 1.66. In the year 2004, what is the difference between the Electricity production(% of total) of Latin America(all income levels) and Electricity production(% of total) of Bulgaria?
Your answer should be very brief. 2.71. In the year 2004, what is the difference between the Electricity production(% of total) of Latin America(all income levels) and Electricity production(% of total) of Iran?
Ensure brevity in your answer.  2.68. In the year 2004, what is the difference between the Electricity production(% of total) in South Asia and Electricity production(% of total) in Bulgaria?
Your response must be concise. 1.05. In the year 2004, what is the difference between the Electricity production(% of total) in South Asia and Electricity production(% of total) in Iran?
Give a very brief answer. 1.03. In the year 2004, what is the difference between the Electricity production(% of total) of Bulgaria and Electricity production(% of total) of Iran?
Keep it short and to the point. -0.03. In the year 2005, what is the difference between the Electricity production(% of total) in Latin America(all income levels) and Electricity production(% of total) in South Asia?
Keep it short and to the point. 1.52. In the year 2005, what is the difference between the Electricity production(% of total) in Latin America(all income levels) and Electricity production(% of total) in Bulgaria?
Offer a terse response. 2.8. In the year 2005, what is the difference between the Electricity production(% of total) in Latin America(all income levels) and Electricity production(% of total) in Iran?
Provide a succinct answer. 2.77. In the year 2005, what is the difference between the Electricity production(% of total) in South Asia and Electricity production(% of total) in Bulgaria?
Keep it short and to the point. 1.28. In the year 2005, what is the difference between the Electricity production(% of total) of South Asia and Electricity production(% of total) of Iran?
Offer a terse response. 1.25. In the year 2005, what is the difference between the Electricity production(% of total) in Bulgaria and Electricity production(% of total) in Iran?
Your answer should be compact. -0.03. In the year 2006, what is the difference between the Electricity production(% of total) of Latin America(all income levels) and Electricity production(% of total) of South Asia?
Offer a terse response. 1.08. In the year 2006, what is the difference between the Electricity production(% of total) in Latin America(all income levels) and Electricity production(% of total) in Bulgaria?
Ensure brevity in your answer.  2.7. In the year 2006, what is the difference between the Electricity production(% of total) of Latin America(all income levels) and Electricity production(% of total) of Iran?
Make the answer very short. 2.68. In the year 2006, what is the difference between the Electricity production(% of total) of South Asia and Electricity production(% of total) of Bulgaria?
Keep it short and to the point. 1.63. In the year 2006, what is the difference between the Electricity production(% of total) of South Asia and Electricity production(% of total) of Iran?
Provide a short and direct response. 1.6. In the year 2006, what is the difference between the Electricity production(% of total) of Bulgaria and Electricity production(% of total) of Iran?
Give a very brief answer. -0.02. In the year 2007, what is the difference between the Electricity production(% of total) in Latin America(all income levels) and Electricity production(% of total) in South Asia?
Offer a very short reply. 1.14. In the year 2007, what is the difference between the Electricity production(% of total) in Latin America(all income levels) and Electricity production(% of total) in Bulgaria?
Provide a short and direct response. 3.02. In the year 2007, what is the difference between the Electricity production(% of total) in Latin America(all income levels) and Electricity production(% of total) in Iran?
Keep it short and to the point. 3.06. In the year 2007, what is the difference between the Electricity production(% of total) of South Asia and Electricity production(% of total) of Bulgaria?
Offer a very short reply. 1.88. In the year 2007, what is the difference between the Electricity production(% of total) of South Asia and Electricity production(% of total) of Iran?
Ensure brevity in your answer.  1.92. In the year 2007, what is the difference between the Electricity production(% of total) of Bulgaria and Electricity production(% of total) of Iran?
Offer a very short reply. 0.04. In the year 2008, what is the difference between the Electricity production(% of total) of Latin America(all income levels) and Electricity production(% of total) of South Asia?
Provide a short and direct response. 0.9. In the year 2008, what is the difference between the Electricity production(% of total) in Latin America(all income levels) and Electricity production(% of total) in Bulgaria?
Your answer should be very brief. 2.93. In the year 2008, what is the difference between the Electricity production(% of total) of Latin America(all income levels) and Electricity production(% of total) of Iran?
Provide a succinct answer. 3.15. In the year 2008, what is the difference between the Electricity production(% of total) in South Asia and Electricity production(% of total) in Bulgaria?
Provide a succinct answer. 2.03. In the year 2008, what is the difference between the Electricity production(% of total) of South Asia and Electricity production(% of total) of Iran?
Offer a terse response. 2.25. In the year 2008, what is the difference between the Electricity production(% of total) of Bulgaria and Electricity production(% of total) of Iran?
Your response must be concise. 0.22. In the year 2009, what is the difference between the Electricity production(% of total) in Latin America(all income levels) and Electricity production(% of total) in South Asia?
Your response must be concise. 0.77. In the year 2009, what is the difference between the Electricity production(% of total) of Latin America(all income levels) and Electricity production(% of total) of Bulgaria?
Provide a short and direct response. 3.04. In the year 2009, what is the difference between the Electricity production(% of total) in Latin America(all income levels) and Electricity production(% of total) in Iran?
Give a very brief answer. 3.52. In the year 2009, what is the difference between the Electricity production(% of total) in South Asia and Electricity production(% of total) in Bulgaria?
Your answer should be compact. 2.27. In the year 2009, what is the difference between the Electricity production(% of total) of South Asia and Electricity production(% of total) of Iran?
Your answer should be very brief. 2.75. In the year 2009, what is the difference between the Electricity production(% of total) in Bulgaria and Electricity production(% of total) in Iran?
Your response must be concise. 0.48. In the year 2010, what is the difference between the Electricity production(% of total) of Latin America(all income levels) and Electricity production(% of total) of South Asia?
Your response must be concise. 1.29. In the year 2010, what is the difference between the Electricity production(% of total) of Latin America(all income levels) and Electricity production(% of total) of Bulgaria?
Offer a very short reply. 2.7. In the year 2010, what is the difference between the Electricity production(% of total) of Latin America(all income levels) and Electricity production(% of total) of Iran?
Keep it short and to the point. 4.22. In the year 2010, what is the difference between the Electricity production(% of total) of South Asia and Electricity production(% of total) of Bulgaria?
Ensure brevity in your answer.  1.41. In the year 2010, what is the difference between the Electricity production(% of total) of South Asia and Electricity production(% of total) of Iran?
Keep it short and to the point. 2.93. In the year 2010, what is the difference between the Electricity production(% of total) in Bulgaria and Electricity production(% of total) in Iran?
Provide a short and direct response. 1.52. In the year 2011, what is the difference between the Electricity production(% of total) of Latin America(all income levels) and Electricity production(% of total) of South Asia?
Offer a terse response. 0.9. In the year 2011, what is the difference between the Electricity production(% of total) of Latin America(all income levels) and Electricity production(% of total) of Bulgaria?
Give a very brief answer. 2.31. In the year 2011, what is the difference between the Electricity production(% of total) in Latin America(all income levels) and Electricity production(% of total) in Iran?
Make the answer very short. 4.24. In the year 2011, what is the difference between the Electricity production(% of total) of South Asia and Electricity production(% of total) of Bulgaria?
Give a very brief answer. 1.41. In the year 2011, what is the difference between the Electricity production(% of total) in South Asia and Electricity production(% of total) in Iran?
Offer a very short reply. 3.34. In the year 2011, what is the difference between the Electricity production(% of total) of Bulgaria and Electricity production(% of total) of Iran?
Keep it short and to the point. 1.94. What is the ratio of the Electricity production(% of total) in Latin America(all income levels) in 2004 to that in 2005?
Provide a succinct answer. 0.96. What is the ratio of the Electricity production(% of total) of South Asia in 2004 to that in 2005?
Provide a succinct answer. 0.82. What is the ratio of the Electricity production(% of total) of Bulgaria in 2004 to that in 2005?
Provide a short and direct response. 0.21. What is the ratio of the Electricity production(% of total) of Iran in 2004 to that in 2005?
Your answer should be compact. 0.71. What is the ratio of the Electricity production(% of total) in Latin America(all income levels) in 2004 to that in 2006?
Give a very brief answer. 0.99. What is the ratio of the Electricity production(% of total) of South Asia in 2004 to that in 2006?
Your answer should be compact. 0.63. What is the ratio of the Electricity production(% of total) in Bulgaria in 2004 to that in 2006?
Ensure brevity in your answer.  0.05. What is the ratio of the Electricity production(% of total) in Iran in 2004 to that in 2006?
Your response must be concise. 0.43. What is the ratio of the Electricity production(% of total) in Latin America(all income levels) in 2004 to that in 2007?
Ensure brevity in your answer.  0.87. What is the ratio of the Electricity production(% of total) in South Asia in 2004 to that in 2007?
Make the answer very short. 0.53. What is the ratio of the Electricity production(% of total) of Bulgaria in 2004 to that in 2007?
Your response must be concise. 0.02. What is the ratio of the Electricity production(% of total) of Iran in 2004 to that in 2007?
Make the answer very short. 0.4. What is the ratio of the Electricity production(% of total) in Latin America(all income levels) in 2004 to that in 2008?
Your answer should be compact. 0.84. What is the ratio of the Electricity production(% of total) in South Asia in 2004 to that in 2008?
Give a very brief answer. 0.45. What is the ratio of the Electricity production(% of total) of Bulgaria in 2004 to that in 2008?
Give a very brief answer. 0.01. What is the ratio of the Electricity production(% of total) of Iran in 2004 to that in 2008?
Provide a succinct answer. 0.31. What is the ratio of the Electricity production(% of total) of Latin America(all income levels) in 2004 to that in 2009?
Provide a short and direct response. 0.75. What is the ratio of the Electricity production(% of total) of South Asia in 2004 to that in 2009?
Keep it short and to the point. 0.37. What is the ratio of the Electricity production(% of total) in Bulgaria in 2004 to that in 2009?
Offer a very short reply. 0. What is the ratio of the Electricity production(% of total) of Iran in 2004 to that in 2009?
Your answer should be compact. 0.27. What is the ratio of the Electricity production(% of total) of Latin America(all income levels) in 2004 to that in 2010?
Give a very brief answer. 0.63. What is the ratio of the Electricity production(% of total) in South Asia in 2004 to that in 2010?
Offer a very short reply. 0.35. What is the ratio of the Electricity production(% of total) in Bulgaria in 2004 to that in 2010?
Provide a short and direct response. 0. What is the ratio of the Electricity production(% of total) in Iran in 2004 to that in 2010?
Offer a terse response. 0.38. What is the ratio of the Electricity production(% of total) in Latin America(all income levels) in 2004 to that in 2011?
Your answer should be compact. 0.62. What is the ratio of the Electricity production(% of total) in South Asia in 2004 to that in 2011?
Your answer should be compact. 0.31. What is the ratio of the Electricity production(% of total) in Bulgaria in 2004 to that in 2011?
Your answer should be compact. 0. What is the ratio of the Electricity production(% of total) in Iran in 2004 to that in 2011?
Make the answer very short. 0.28. What is the ratio of the Electricity production(% of total) of Latin America(all income levels) in 2005 to that in 2006?
Make the answer very short. 1.02. What is the ratio of the Electricity production(% of total) of South Asia in 2005 to that in 2006?
Give a very brief answer. 0.77. What is the ratio of the Electricity production(% of total) of Bulgaria in 2005 to that in 2006?
Make the answer very short. 0.26. What is the ratio of the Electricity production(% of total) in Iran in 2005 to that in 2006?
Offer a very short reply. 0.61. What is the ratio of the Electricity production(% of total) in Latin America(all income levels) in 2005 to that in 2007?
Your response must be concise. 0.9. What is the ratio of the Electricity production(% of total) in South Asia in 2005 to that in 2007?
Make the answer very short. 0.65. What is the ratio of the Electricity production(% of total) in Bulgaria in 2005 to that in 2007?
Offer a very short reply. 0.1. What is the ratio of the Electricity production(% of total) in Iran in 2005 to that in 2007?
Offer a very short reply. 0.57. What is the ratio of the Electricity production(% of total) of Latin America(all income levels) in 2005 to that in 2008?
Ensure brevity in your answer.  0.87. What is the ratio of the Electricity production(% of total) of South Asia in 2005 to that in 2008?
Make the answer very short. 0.55. What is the ratio of the Electricity production(% of total) in Bulgaria in 2005 to that in 2008?
Keep it short and to the point. 0.04. What is the ratio of the Electricity production(% of total) of Iran in 2005 to that in 2008?
Your answer should be very brief. 0.44. What is the ratio of the Electricity production(% of total) of Latin America(all income levels) in 2005 to that in 2009?
Provide a succinct answer. 0.78. What is the ratio of the Electricity production(% of total) in South Asia in 2005 to that in 2009?
Keep it short and to the point. 0.45. What is the ratio of the Electricity production(% of total) in Bulgaria in 2005 to that in 2009?
Your answer should be very brief. 0.02. What is the ratio of the Electricity production(% of total) of Iran in 2005 to that in 2009?
Your response must be concise. 0.39. What is the ratio of the Electricity production(% of total) in Latin America(all income levels) in 2005 to that in 2010?
Your response must be concise. 0.65. What is the ratio of the Electricity production(% of total) in South Asia in 2005 to that in 2010?
Ensure brevity in your answer.  0.43. What is the ratio of the Electricity production(% of total) in Bulgaria in 2005 to that in 2010?
Ensure brevity in your answer.  0.01. What is the ratio of the Electricity production(% of total) in Iran in 2005 to that in 2010?
Your answer should be compact. 0.54. What is the ratio of the Electricity production(% of total) in Latin America(all income levels) in 2005 to that in 2011?
Provide a short and direct response. 0.65. What is the ratio of the Electricity production(% of total) in South Asia in 2005 to that in 2011?
Provide a succinct answer. 0.38. What is the ratio of the Electricity production(% of total) in Bulgaria in 2005 to that in 2011?
Provide a succinct answer. 0.01. What is the ratio of the Electricity production(% of total) in Iran in 2005 to that in 2011?
Your answer should be very brief. 0.4. What is the ratio of the Electricity production(% of total) in Latin America(all income levels) in 2006 to that in 2007?
Your answer should be very brief. 0.88. What is the ratio of the Electricity production(% of total) of South Asia in 2006 to that in 2007?
Offer a very short reply. 0.84. What is the ratio of the Electricity production(% of total) of Bulgaria in 2006 to that in 2007?
Provide a short and direct response. 0.4. What is the ratio of the Electricity production(% of total) in Iran in 2006 to that in 2007?
Give a very brief answer. 0.93. What is the ratio of the Electricity production(% of total) in Latin America(all income levels) in 2006 to that in 2008?
Your answer should be compact. 0.85. What is the ratio of the Electricity production(% of total) of South Asia in 2006 to that in 2008?
Make the answer very short. 0.71. What is the ratio of the Electricity production(% of total) in Bulgaria in 2006 to that in 2008?
Provide a succinct answer. 0.14. What is the ratio of the Electricity production(% of total) in Iran in 2006 to that in 2008?
Keep it short and to the point. 0.71. What is the ratio of the Electricity production(% of total) of Latin America(all income levels) in 2006 to that in 2009?
Provide a short and direct response. 0.76. What is the ratio of the Electricity production(% of total) in South Asia in 2006 to that in 2009?
Your response must be concise. 0.59. What is the ratio of the Electricity production(% of total) of Bulgaria in 2006 to that in 2009?
Keep it short and to the point. 0.08. What is the ratio of the Electricity production(% of total) in Iran in 2006 to that in 2009?
Keep it short and to the point. 0.63. What is the ratio of the Electricity production(% of total) of Latin America(all income levels) in 2006 to that in 2010?
Your response must be concise. 0.64. What is the ratio of the Electricity production(% of total) of South Asia in 2006 to that in 2010?
Your answer should be very brief. 0.56. What is the ratio of the Electricity production(% of total) in Bulgaria in 2006 to that in 2010?
Provide a succinct answer. 0.03. What is the ratio of the Electricity production(% of total) in Iran in 2006 to that in 2010?
Offer a very short reply. 0.87. What is the ratio of the Electricity production(% of total) of Latin America(all income levels) in 2006 to that in 2011?
Your answer should be very brief. 0.63. What is the ratio of the Electricity production(% of total) of South Asia in 2006 to that in 2011?
Your answer should be compact. 0.48. What is the ratio of the Electricity production(% of total) in Bulgaria in 2006 to that in 2011?
Ensure brevity in your answer.  0.02. What is the ratio of the Electricity production(% of total) of Iran in 2006 to that in 2011?
Provide a succinct answer. 0.65. What is the ratio of the Electricity production(% of total) of Latin America(all income levels) in 2007 to that in 2008?
Your answer should be compact. 0.96. What is the ratio of the Electricity production(% of total) of South Asia in 2007 to that in 2008?
Offer a very short reply. 0.85. What is the ratio of the Electricity production(% of total) of Bulgaria in 2007 to that in 2008?
Provide a succinct answer. 0.35. What is the ratio of the Electricity production(% of total) of Iran in 2007 to that in 2008?
Your response must be concise. 0.77. What is the ratio of the Electricity production(% of total) in Latin America(all income levels) in 2007 to that in 2009?
Your answer should be very brief. 0.86. What is the ratio of the Electricity production(% of total) of South Asia in 2007 to that in 2009?
Your answer should be very brief. 0.7. What is the ratio of the Electricity production(% of total) of Bulgaria in 2007 to that in 2009?
Ensure brevity in your answer.  0.19. What is the ratio of the Electricity production(% of total) in Iran in 2007 to that in 2009?
Keep it short and to the point. 0.68. What is the ratio of the Electricity production(% of total) of Latin America(all income levels) in 2007 to that in 2010?
Offer a terse response. 0.73. What is the ratio of the Electricity production(% of total) in South Asia in 2007 to that in 2010?
Your answer should be compact. 0.66. What is the ratio of the Electricity production(% of total) in Bulgaria in 2007 to that in 2010?
Your answer should be compact. 0.07. What is the ratio of the Electricity production(% of total) of Iran in 2007 to that in 2010?
Provide a succinct answer. 0.94. What is the ratio of the Electricity production(% of total) of Latin America(all income levels) in 2007 to that in 2011?
Your answer should be compact. 0.72. What is the ratio of the Electricity production(% of total) of South Asia in 2007 to that in 2011?
Your answer should be very brief. 0.58. What is the ratio of the Electricity production(% of total) in Bulgaria in 2007 to that in 2011?
Offer a terse response. 0.05. What is the ratio of the Electricity production(% of total) in Iran in 2007 to that in 2011?
Provide a short and direct response. 0.7. What is the ratio of the Electricity production(% of total) in Latin America(all income levels) in 2008 to that in 2009?
Your answer should be very brief. 0.9. What is the ratio of the Electricity production(% of total) in South Asia in 2008 to that in 2009?
Your response must be concise. 0.82. What is the ratio of the Electricity production(% of total) in Bulgaria in 2008 to that in 2009?
Give a very brief answer. 0.53. What is the ratio of the Electricity production(% of total) of Iran in 2008 to that in 2009?
Ensure brevity in your answer.  0.89. What is the ratio of the Electricity production(% of total) of Latin America(all income levels) in 2008 to that in 2010?
Make the answer very short. 0.76. What is the ratio of the Electricity production(% of total) of South Asia in 2008 to that in 2010?
Keep it short and to the point. 0.78. What is the ratio of the Electricity production(% of total) of Bulgaria in 2008 to that in 2010?
Offer a terse response. 0.19. What is the ratio of the Electricity production(% of total) of Iran in 2008 to that in 2010?
Offer a very short reply. 1.23. What is the ratio of the Electricity production(% of total) of Latin America(all income levels) in 2008 to that in 2011?
Ensure brevity in your answer.  0.75. What is the ratio of the Electricity production(% of total) of South Asia in 2008 to that in 2011?
Make the answer very short. 0.68. What is the ratio of the Electricity production(% of total) of Bulgaria in 2008 to that in 2011?
Offer a terse response. 0.15. What is the ratio of the Electricity production(% of total) of Iran in 2008 to that in 2011?
Your answer should be compact. 0.92. What is the ratio of the Electricity production(% of total) of Latin America(all income levels) in 2009 to that in 2010?
Make the answer very short. 0.84. What is the ratio of the Electricity production(% of total) in South Asia in 2009 to that in 2010?
Your answer should be very brief. 0.95. What is the ratio of the Electricity production(% of total) in Bulgaria in 2009 to that in 2010?
Your response must be concise. 0.37. What is the ratio of the Electricity production(% of total) in Iran in 2009 to that in 2010?
Make the answer very short. 1.38. What is the ratio of the Electricity production(% of total) of Latin America(all income levels) in 2009 to that in 2011?
Give a very brief answer. 0.83. What is the ratio of the Electricity production(% of total) in South Asia in 2009 to that in 2011?
Offer a terse response. 0.83. What is the ratio of the Electricity production(% of total) of Bulgaria in 2009 to that in 2011?
Your answer should be very brief. 0.29. What is the ratio of the Electricity production(% of total) of Iran in 2009 to that in 2011?
Your response must be concise. 1.03. What is the ratio of the Electricity production(% of total) in South Asia in 2010 to that in 2011?
Your response must be concise. 0.87. What is the ratio of the Electricity production(% of total) of Bulgaria in 2010 to that in 2011?
Your response must be concise. 0.78. What is the ratio of the Electricity production(% of total) of Iran in 2010 to that in 2011?
Provide a short and direct response. 0.75. What is the difference between the highest and the second highest Electricity production(% of total) in Latin America(all income levels)?
Provide a succinct answer. 0.05. What is the difference between the highest and the second highest Electricity production(% of total) in South Asia?
Keep it short and to the point. 0.44. What is the difference between the highest and the second highest Electricity production(% of total) of Bulgaria?
Make the answer very short. 0.44. What is the difference between the highest and the second highest Electricity production(% of total) in Iran?
Provide a succinct answer. 0. What is the difference between the highest and the lowest Electricity production(% of total) of Latin America(all income levels)?
Keep it short and to the point. 1.63. What is the difference between the highest and the lowest Electricity production(% of total) in South Asia?
Make the answer very short. 2.39. What is the difference between the highest and the lowest Electricity production(% of total) of Bulgaria?
Offer a terse response. 2.03. What is the difference between the highest and the lowest Electricity production(% of total) of Iran?
Give a very brief answer. 0.07. 